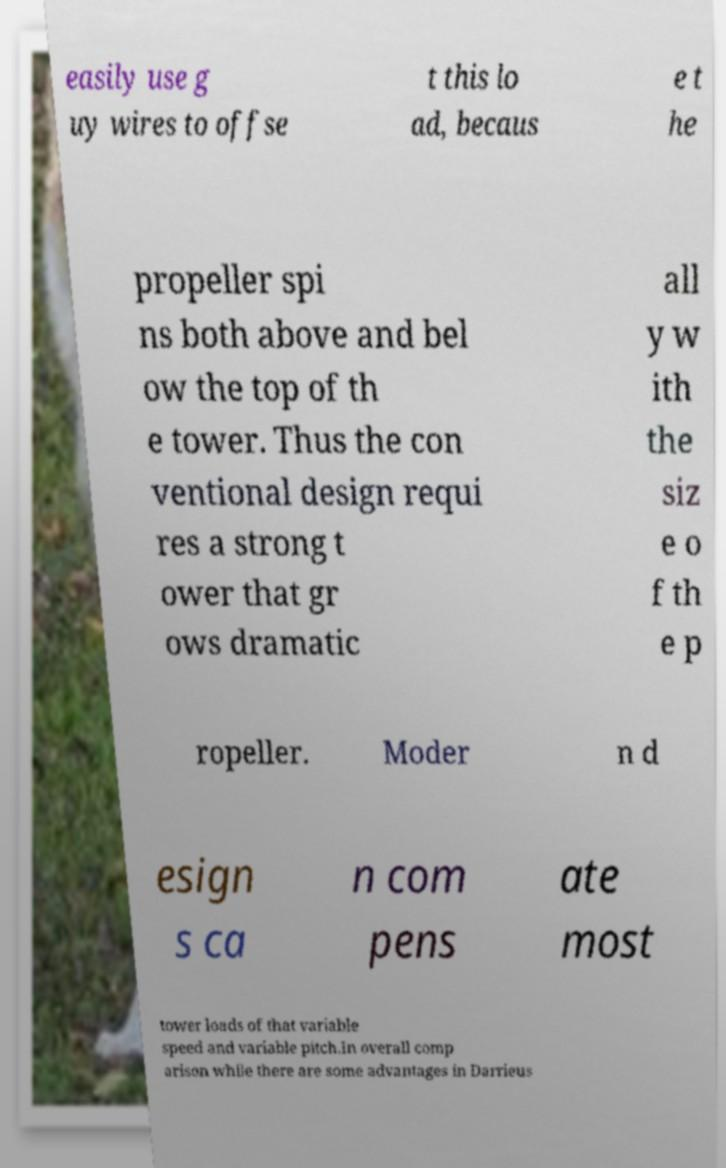There's text embedded in this image that I need extracted. Can you transcribe it verbatim? easily use g uy wires to offse t this lo ad, becaus e t he propeller spi ns both above and bel ow the top of th e tower. Thus the con ventional design requi res a strong t ower that gr ows dramatic all y w ith the siz e o f th e p ropeller. Moder n d esign s ca n com pens ate most tower loads of that variable speed and variable pitch.In overall comp arison while there are some advantages in Darrieus 